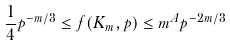<formula> <loc_0><loc_0><loc_500><loc_500>\frac { 1 } { 4 } p ^ { - m / 3 } \leq f ( K _ { m } , p ) \leq m ^ { A } p ^ { - 2 m / 3 }</formula> 